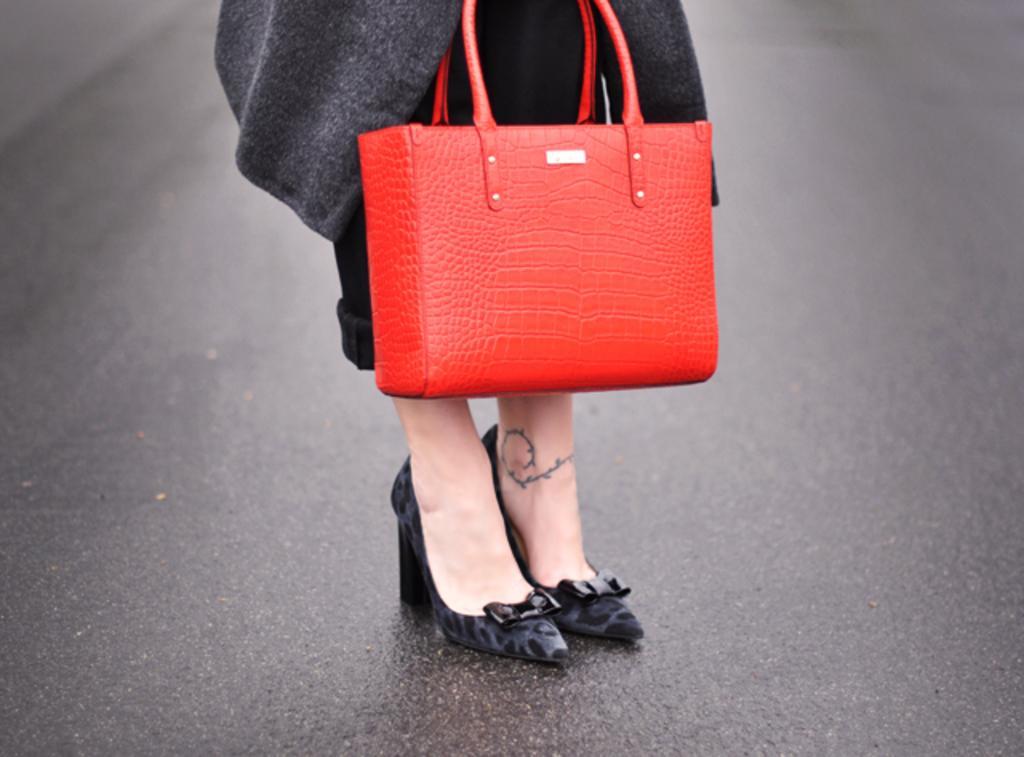Please provide a concise description of this image. This image contains a person wearing some shoes. There is a red bag. She is standing on the road. 